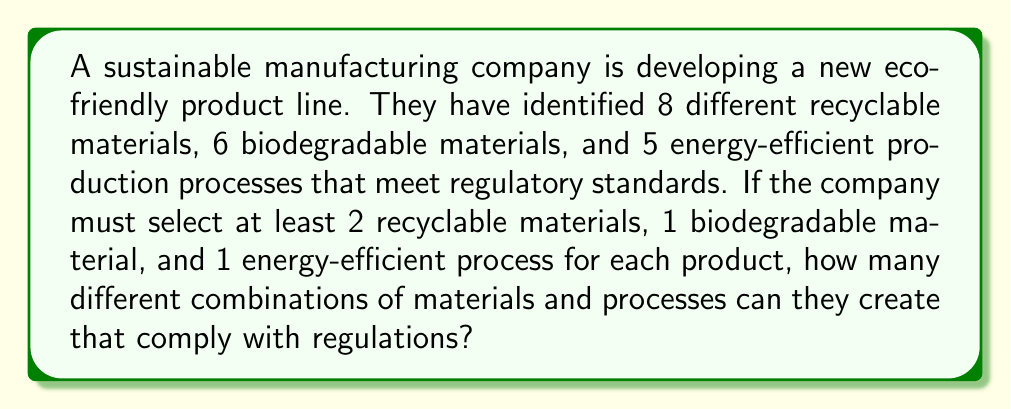Help me with this question. Let's break this problem down step by step:

1) First, we need to calculate the number of ways to choose recyclable materials:
   - We must choose at least 2 out of 8 recyclable materials
   - This means we can choose 2, 3, 4, 5, 6, 7, or 8 materials
   - We can represent this as a sum of combinations:
     $$\sum_{i=2}^{8} \binom{8}{i}$$

2) For biodegradable materials:
   - We must choose at least 1 out of 6 materials
   - This means we can choose 1, 2, 3, 4, 5, or 6 materials
   - Represented as:
     $$\sum_{j=1}^{6} \binom{6}{j}$$

3) For energy-efficient processes:
   - We must choose at least 1 out of 5 processes
   - This means we can choose 1, 2, 3, 4, or 5 processes
   - Represented as:
     $$\sum_{k=1}^{5} \binom{5}{k}$$

4) Now, let's calculate each sum:
   $$\sum_{i=2}^{8} \binom{8}{i} = 28 + 56 + 70 + 56 + 28 + 8 + 1 = 247$$
   $$\sum_{j=1}^{6} \binom{6}{j} = 6 + 15 + 20 + 15 + 6 + 1 = 63$$
   $$\sum_{k=1}^{5} \binom{5}{k} = 5 + 10 + 10 + 5 + 1 = 31$$

5) According to the multiplication principle, the total number of combinations is the product of these sums:

   $$247 \times 63 \times 31 = 482,811$$
Answer: 482,811 combinations 